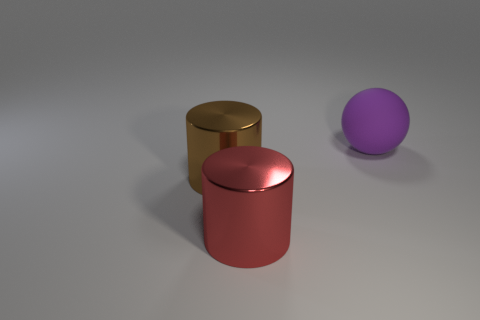Add 1 large shiny cylinders. How many objects exist? 4 Subtract all cylinders. How many objects are left? 1 Add 1 metal cylinders. How many metal cylinders are left? 3 Add 1 matte objects. How many matte objects exist? 2 Subtract 0 green blocks. How many objects are left? 3 Subtract all red shiny cylinders. Subtract all big purple shiny cylinders. How many objects are left? 2 